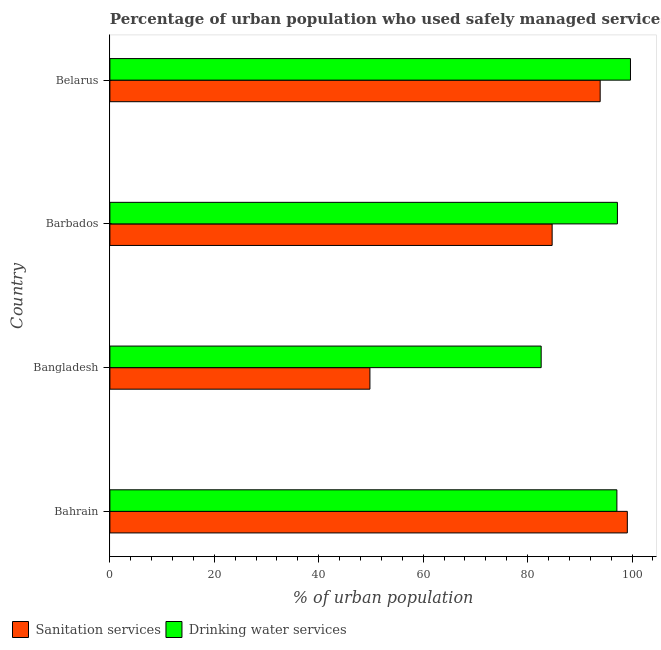How many different coloured bars are there?
Give a very brief answer. 2. How many groups of bars are there?
Your answer should be very brief. 4. Are the number of bars on each tick of the Y-axis equal?
Ensure brevity in your answer.  Yes. How many bars are there on the 1st tick from the bottom?
Make the answer very short. 2. In how many cases, is the number of bars for a given country not equal to the number of legend labels?
Keep it short and to the point. 0. What is the percentage of urban population who used sanitation services in Bahrain?
Your response must be concise. 99.1. Across all countries, what is the maximum percentage of urban population who used drinking water services?
Give a very brief answer. 99.7. Across all countries, what is the minimum percentage of urban population who used drinking water services?
Offer a terse response. 82.6. In which country was the percentage of urban population who used sanitation services maximum?
Offer a very short reply. Bahrain. What is the total percentage of urban population who used drinking water services in the graph?
Provide a succinct answer. 376.6. What is the difference between the percentage of urban population who used drinking water services in Barbados and that in Belarus?
Give a very brief answer. -2.5. What is the difference between the percentage of urban population who used sanitation services in Barbados and the percentage of urban population who used drinking water services in Belarus?
Your answer should be very brief. -15. What is the average percentage of urban population who used sanitation services per country?
Offer a terse response. 81.88. What is the difference between the percentage of urban population who used sanitation services and percentage of urban population who used drinking water services in Bangladesh?
Offer a very short reply. -32.8. What is the ratio of the percentage of urban population who used sanitation services in Bahrain to that in Barbados?
Your response must be concise. 1.17. Is the percentage of urban population who used drinking water services in Bahrain less than that in Belarus?
Offer a terse response. Yes. What does the 1st bar from the top in Bahrain represents?
Your answer should be compact. Drinking water services. What does the 2nd bar from the bottom in Belarus represents?
Your answer should be very brief. Drinking water services. Are all the bars in the graph horizontal?
Give a very brief answer. Yes. Are the values on the major ticks of X-axis written in scientific E-notation?
Keep it short and to the point. No. Does the graph contain any zero values?
Make the answer very short. No. How many legend labels are there?
Give a very brief answer. 2. How are the legend labels stacked?
Your answer should be compact. Horizontal. What is the title of the graph?
Make the answer very short. Percentage of urban population who used safely managed services in 1997. Does "Resident" appear as one of the legend labels in the graph?
Your answer should be very brief. No. What is the label or title of the X-axis?
Your answer should be very brief. % of urban population. What is the % of urban population of Sanitation services in Bahrain?
Your response must be concise. 99.1. What is the % of urban population of Drinking water services in Bahrain?
Provide a succinct answer. 97.1. What is the % of urban population of Sanitation services in Bangladesh?
Your answer should be very brief. 49.8. What is the % of urban population in Drinking water services in Bangladesh?
Make the answer very short. 82.6. What is the % of urban population in Sanitation services in Barbados?
Your answer should be compact. 84.7. What is the % of urban population in Drinking water services in Barbados?
Keep it short and to the point. 97.2. What is the % of urban population of Sanitation services in Belarus?
Offer a very short reply. 93.9. What is the % of urban population of Drinking water services in Belarus?
Your answer should be compact. 99.7. Across all countries, what is the maximum % of urban population in Sanitation services?
Give a very brief answer. 99.1. Across all countries, what is the maximum % of urban population in Drinking water services?
Provide a succinct answer. 99.7. Across all countries, what is the minimum % of urban population of Sanitation services?
Your answer should be very brief. 49.8. Across all countries, what is the minimum % of urban population in Drinking water services?
Provide a succinct answer. 82.6. What is the total % of urban population of Sanitation services in the graph?
Offer a terse response. 327.5. What is the total % of urban population of Drinking water services in the graph?
Offer a terse response. 376.6. What is the difference between the % of urban population of Sanitation services in Bahrain and that in Bangladesh?
Make the answer very short. 49.3. What is the difference between the % of urban population of Drinking water services in Bahrain and that in Barbados?
Provide a short and direct response. -0.1. What is the difference between the % of urban population of Sanitation services in Bahrain and that in Belarus?
Provide a succinct answer. 5.2. What is the difference between the % of urban population in Drinking water services in Bahrain and that in Belarus?
Your response must be concise. -2.6. What is the difference between the % of urban population of Sanitation services in Bangladesh and that in Barbados?
Keep it short and to the point. -34.9. What is the difference between the % of urban population of Drinking water services in Bangladesh and that in Barbados?
Provide a short and direct response. -14.6. What is the difference between the % of urban population of Sanitation services in Bangladesh and that in Belarus?
Offer a very short reply. -44.1. What is the difference between the % of urban population of Drinking water services in Bangladesh and that in Belarus?
Provide a short and direct response. -17.1. What is the difference between the % of urban population of Sanitation services in Bahrain and the % of urban population of Drinking water services in Bangladesh?
Offer a terse response. 16.5. What is the difference between the % of urban population in Sanitation services in Bahrain and the % of urban population in Drinking water services in Barbados?
Your answer should be very brief. 1.9. What is the difference between the % of urban population of Sanitation services in Bahrain and the % of urban population of Drinking water services in Belarus?
Provide a short and direct response. -0.6. What is the difference between the % of urban population of Sanitation services in Bangladesh and the % of urban population of Drinking water services in Barbados?
Ensure brevity in your answer.  -47.4. What is the difference between the % of urban population of Sanitation services in Bangladesh and the % of urban population of Drinking water services in Belarus?
Provide a short and direct response. -49.9. What is the average % of urban population in Sanitation services per country?
Your answer should be compact. 81.88. What is the average % of urban population in Drinking water services per country?
Give a very brief answer. 94.15. What is the difference between the % of urban population of Sanitation services and % of urban population of Drinking water services in Bahrain?
Make the answer very short. 2. What is the difference between the % of urban population in Sanitation services and % of urban population in Drinking water services in Bangladesh?
Offer a very short reply. -32.8. What is the ratio of the % of urban population in Sanitation services in Bahrain to that in Bangladesh?
Your answer should be compact. 1.99. What is the ratio of the % of urban population of Drinking water services in Bahrain to that in Bangladesh?
Your response must be concise. 1.18. What is the ratio of the % of urban population of Sanitation services in Bahrain to that in Barbados?
Provide a succinct answer. 1.17. What is the ratio of the % of urban population of Drinking water services in Bahrain to that in Barbados?
Your response must be concise. 1. What is the ratio of the % of urban population of Sanitation services in Bahrain to that in Belarus?
Your answer should be compact. 1.06. What is the ratio of the % of urban population in Drinking water services in Bahrain to that in Belarus?
Your answer should be compact. 0.97. What is the ratio of the % of urban population in Sanitation services in Bangladesh to that in Barbados?
Offer a very short reply. 0.59. What is the ratio of the % of urban population in Drinking water services in Bangladesh to that in Barbados?
Your answer should be very brief. 0.85. What is the ratio of the % of urban population in Sanitation services in Bangladesh to that in Belarus?
Keep it short and to the point. 0.53. What is the ratio of the % of urban population in Drinking water services in Bangladesh to that in Belarus?
Your answer should be very brief. 0.83. What is the ratio of the % of urban population in Sanitation services in Barbados to that in Belarus?
Make the answer very short. 0.9. What is the ratio of the % of urban population of Drinking water services in Barbados to that in Belarus?
Give a very brief answer. 0.97. What is the difference between the highest and the second highest % of urban population of Sanitation services?
Make the answer very short. 5.2. What is the difference between the highest and the lowest % of urban population of Sanitation services?
Ensure brevity in your answer.  49.3. 